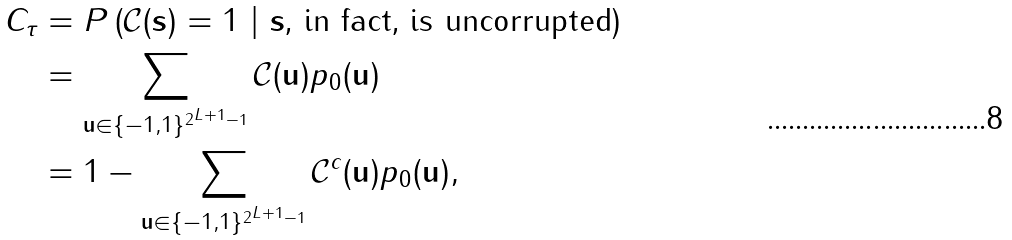<formula> <loc_0><loc_0><loc_500><loc_500>C _ { \tau } & = P \left ( \mathcal { C } ( \mathbf s ) = 1 \text { } | \text { } \mathbf s \text {, in fact, is uncorrupted} \right ) \\ & = \sum _ { \mathbf u \in \{ - 1 , 1 \} ^ { 2 ^ { L + 1 } - 1 } } \mathcal { C } ( \mathbf u ) p _ { 0 } ( \mathbf u ) \\ & = 1 - \sum _ { \mathbf u \in \{ - 1 , 1 \} ^ { 2 ^ { L + 1 } - 1 } } \mathcal { C } ^ { c } ( \mathbf u ) p _ { 0 } ( \mathbf u ) ,</formula> 